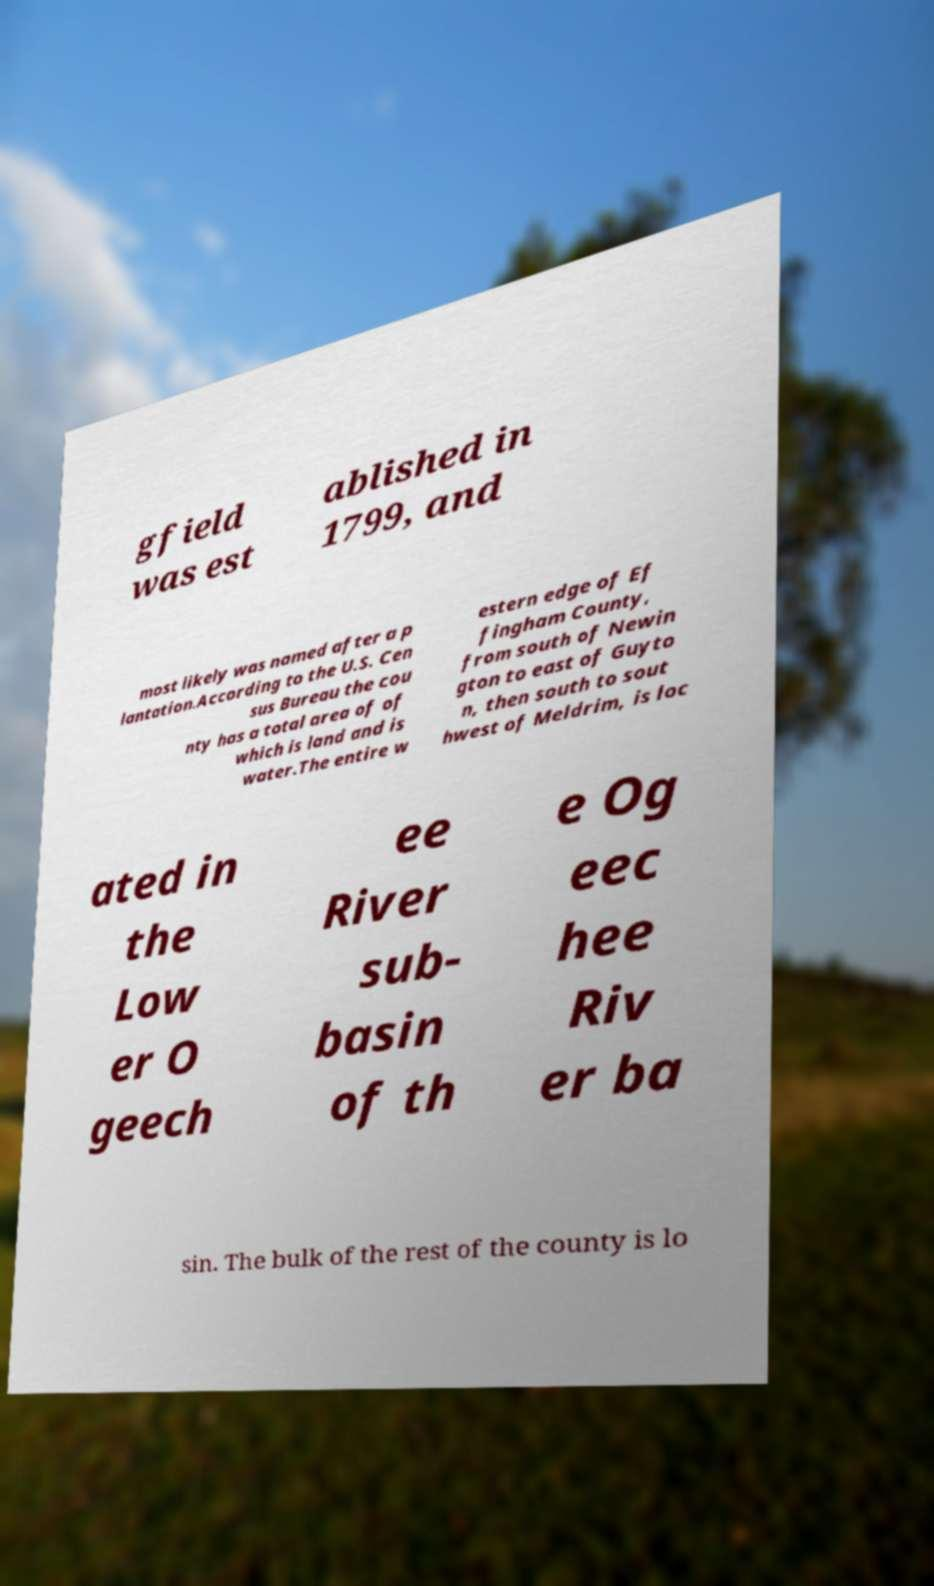Could you assist in decoding the text presented in this image and type it out clearly? gfield was est ablished in 1799, and most likely was named after a p lantation.According to the U.S. Cen sus Bureau the cou nty has a total area of of which is land and is water.The entire w estern edge of Ef fingham County, from south of Newin gton to east of Guyto n, then south to sout hwest of Meldrim, is loc ated in the Low er O geech ee River sub- basin of th e Og eec hee Riv er ba sin. The bulk of the rest of the county is lo 